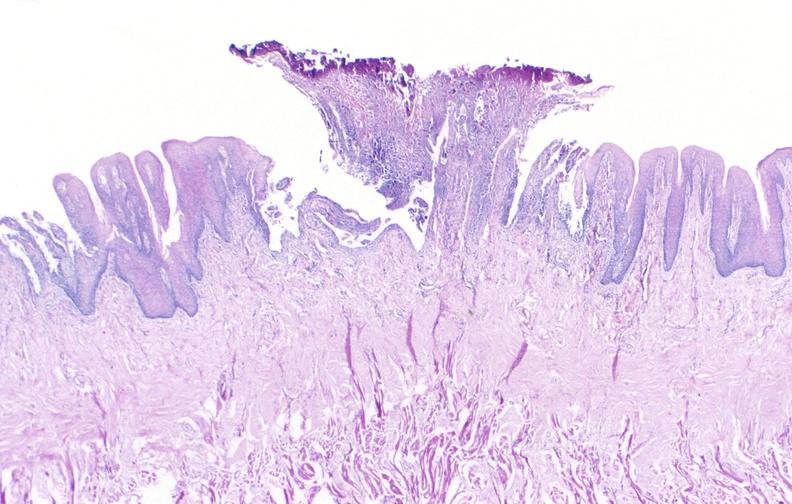does medial aspect show tongue, herpes ulcer?
Answer the question using a single word or phrase. No 